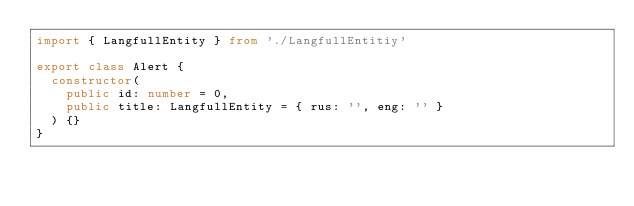Convert code to text. <code><loc_0><loc_0><loc_500><loc_500><_TypeScript_>import { LangfullEntity } from './LangfullEntitiy'

export class Alert {
  constructor(
    public id: number = 0,
    public title: LangfullEntity = { rus: '', eng: '' }
  ) {}
}
</code> 